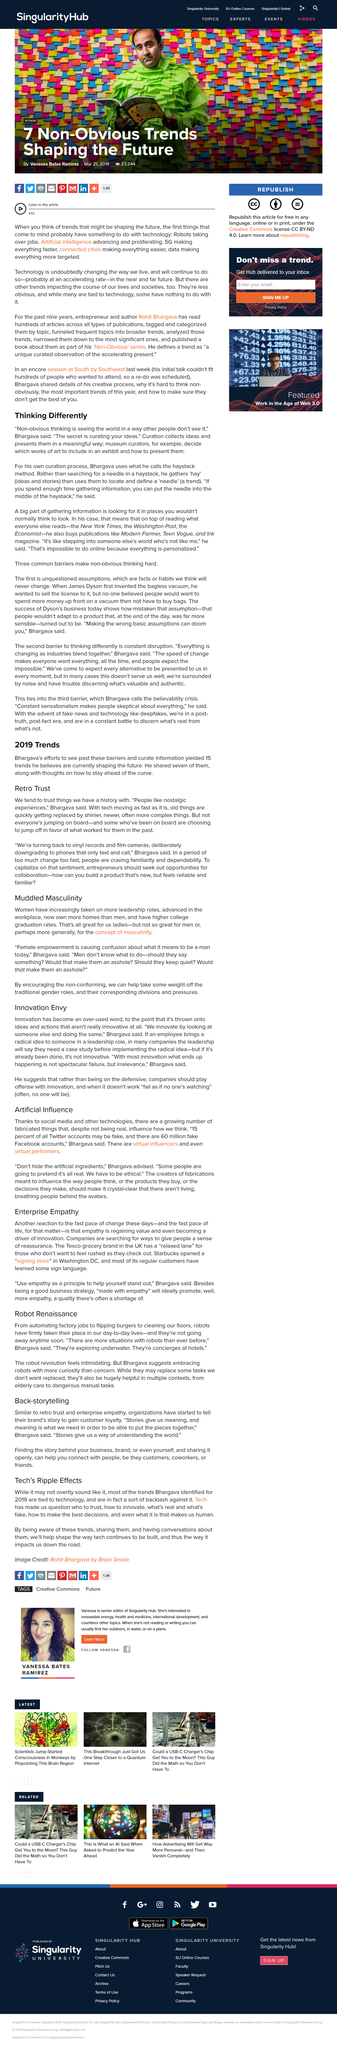Indicate a few pertinent items in this graphic. I declare that Starbucks has opened a signing store in Washington DC. In 2019, Bhargava yielded a total of 15 trends. Old things are quickly getting replaced by newer things because technology is advancing at a rapid pace. The article discusses the ripple effects of technology on various aspects of society. Bhargava suggests embracing robots with more curiosity than concern. 